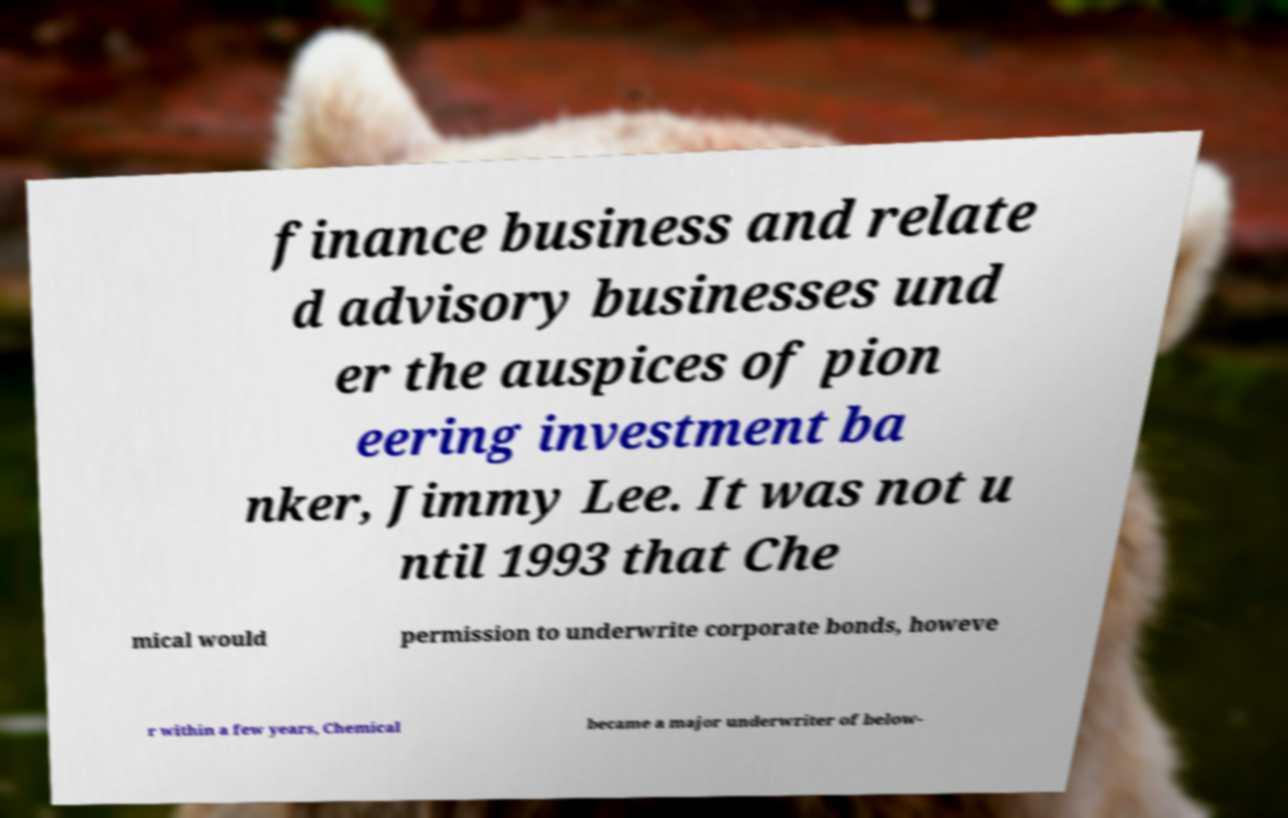Please read and relay the text visible in this image. What does it say? finance business and relate d advisory businesses und er the auspices of pion eering investment ba nker, Jimmy Lee. It was not u ntil 1993 that Che mical would permission to underwrite corporate bonds, howeve r within a few years, Chemical became a major underwriter of below- 